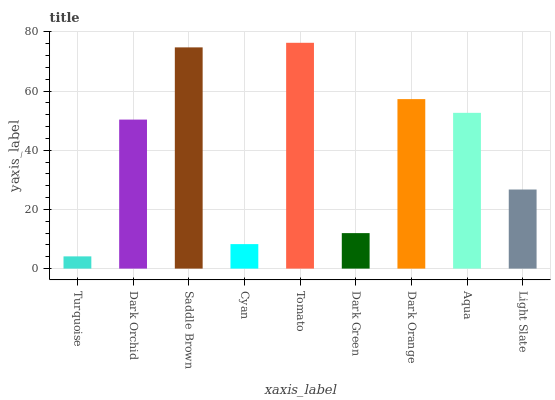Is Turquoise the minimum?
Answer yes or no. Yes. Is Tomato the maximum?
Answer yes or no. Yes. Is Dark Orchid the minimum?
Answer yes or no. No. Is Dark Orchid the maximum?
Answer yes or no. No. Is Dark Orchid greater than Turquoise?
Answer yes or no. Yes. Is Turquoise less than Dark Orchid?
Answer yes or no. Yes. Is Turquoise greater than Dark Orchid?
Answer yes or no. No. Is Dark Orchid less than Turquoise?
Answer yes or no. No. Is Dark Orchid the high median?
Answer yes or no. Yes. Is Dark Orchid the low median?
Answer yes or no. Yes. Is Dark Green the high median?
Answer yes or no. No. Is Saddle Brown the low median?
Answer yes or no. No. 